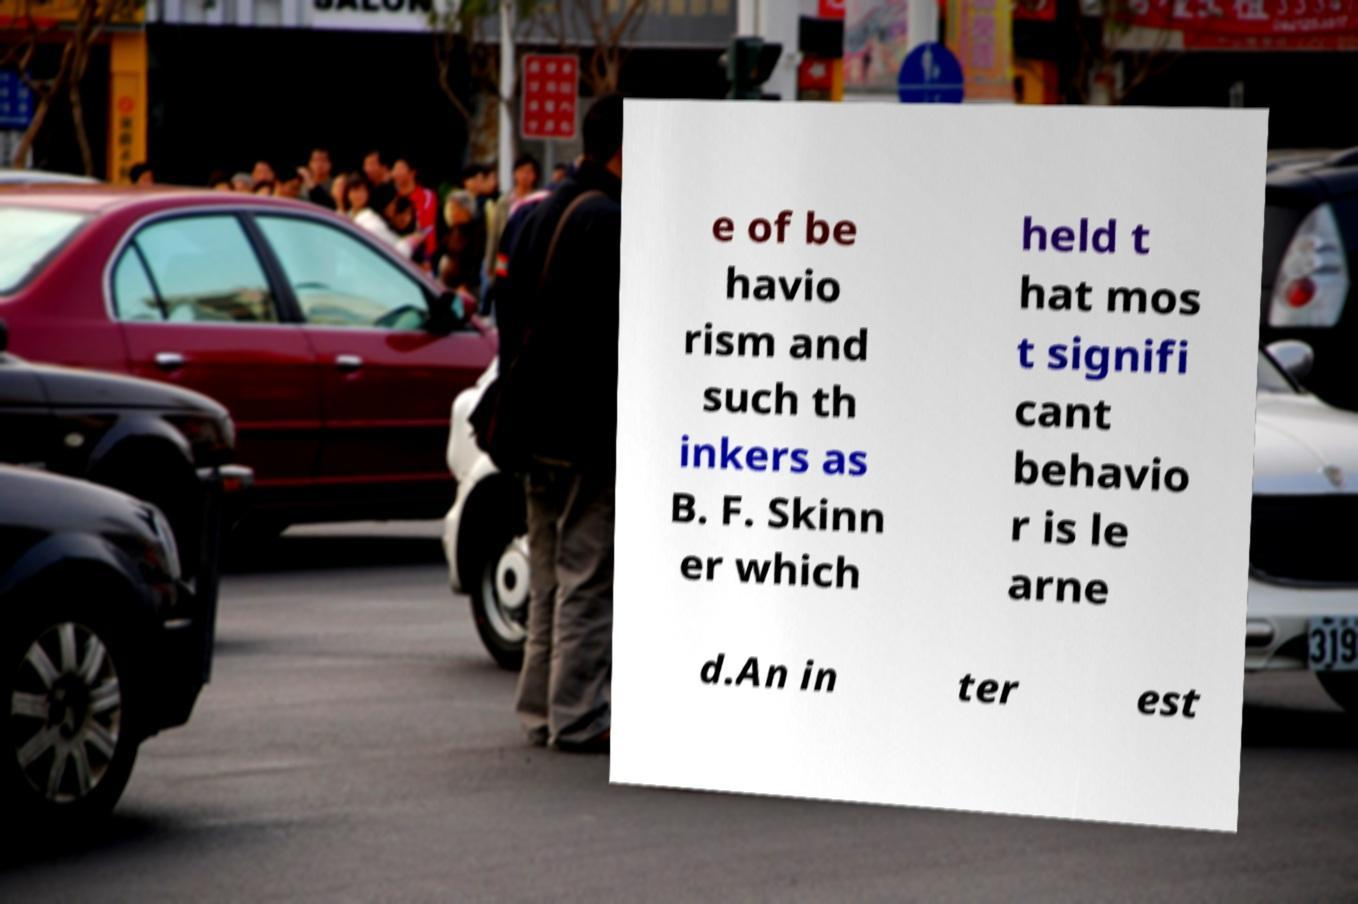Can you accurately transcribe the text from the provided image for me? e of be havio rism and such th inkers as B. F. Skinn er which held t hat mos t signifi cant behavio r is le arne d.An in ter est 